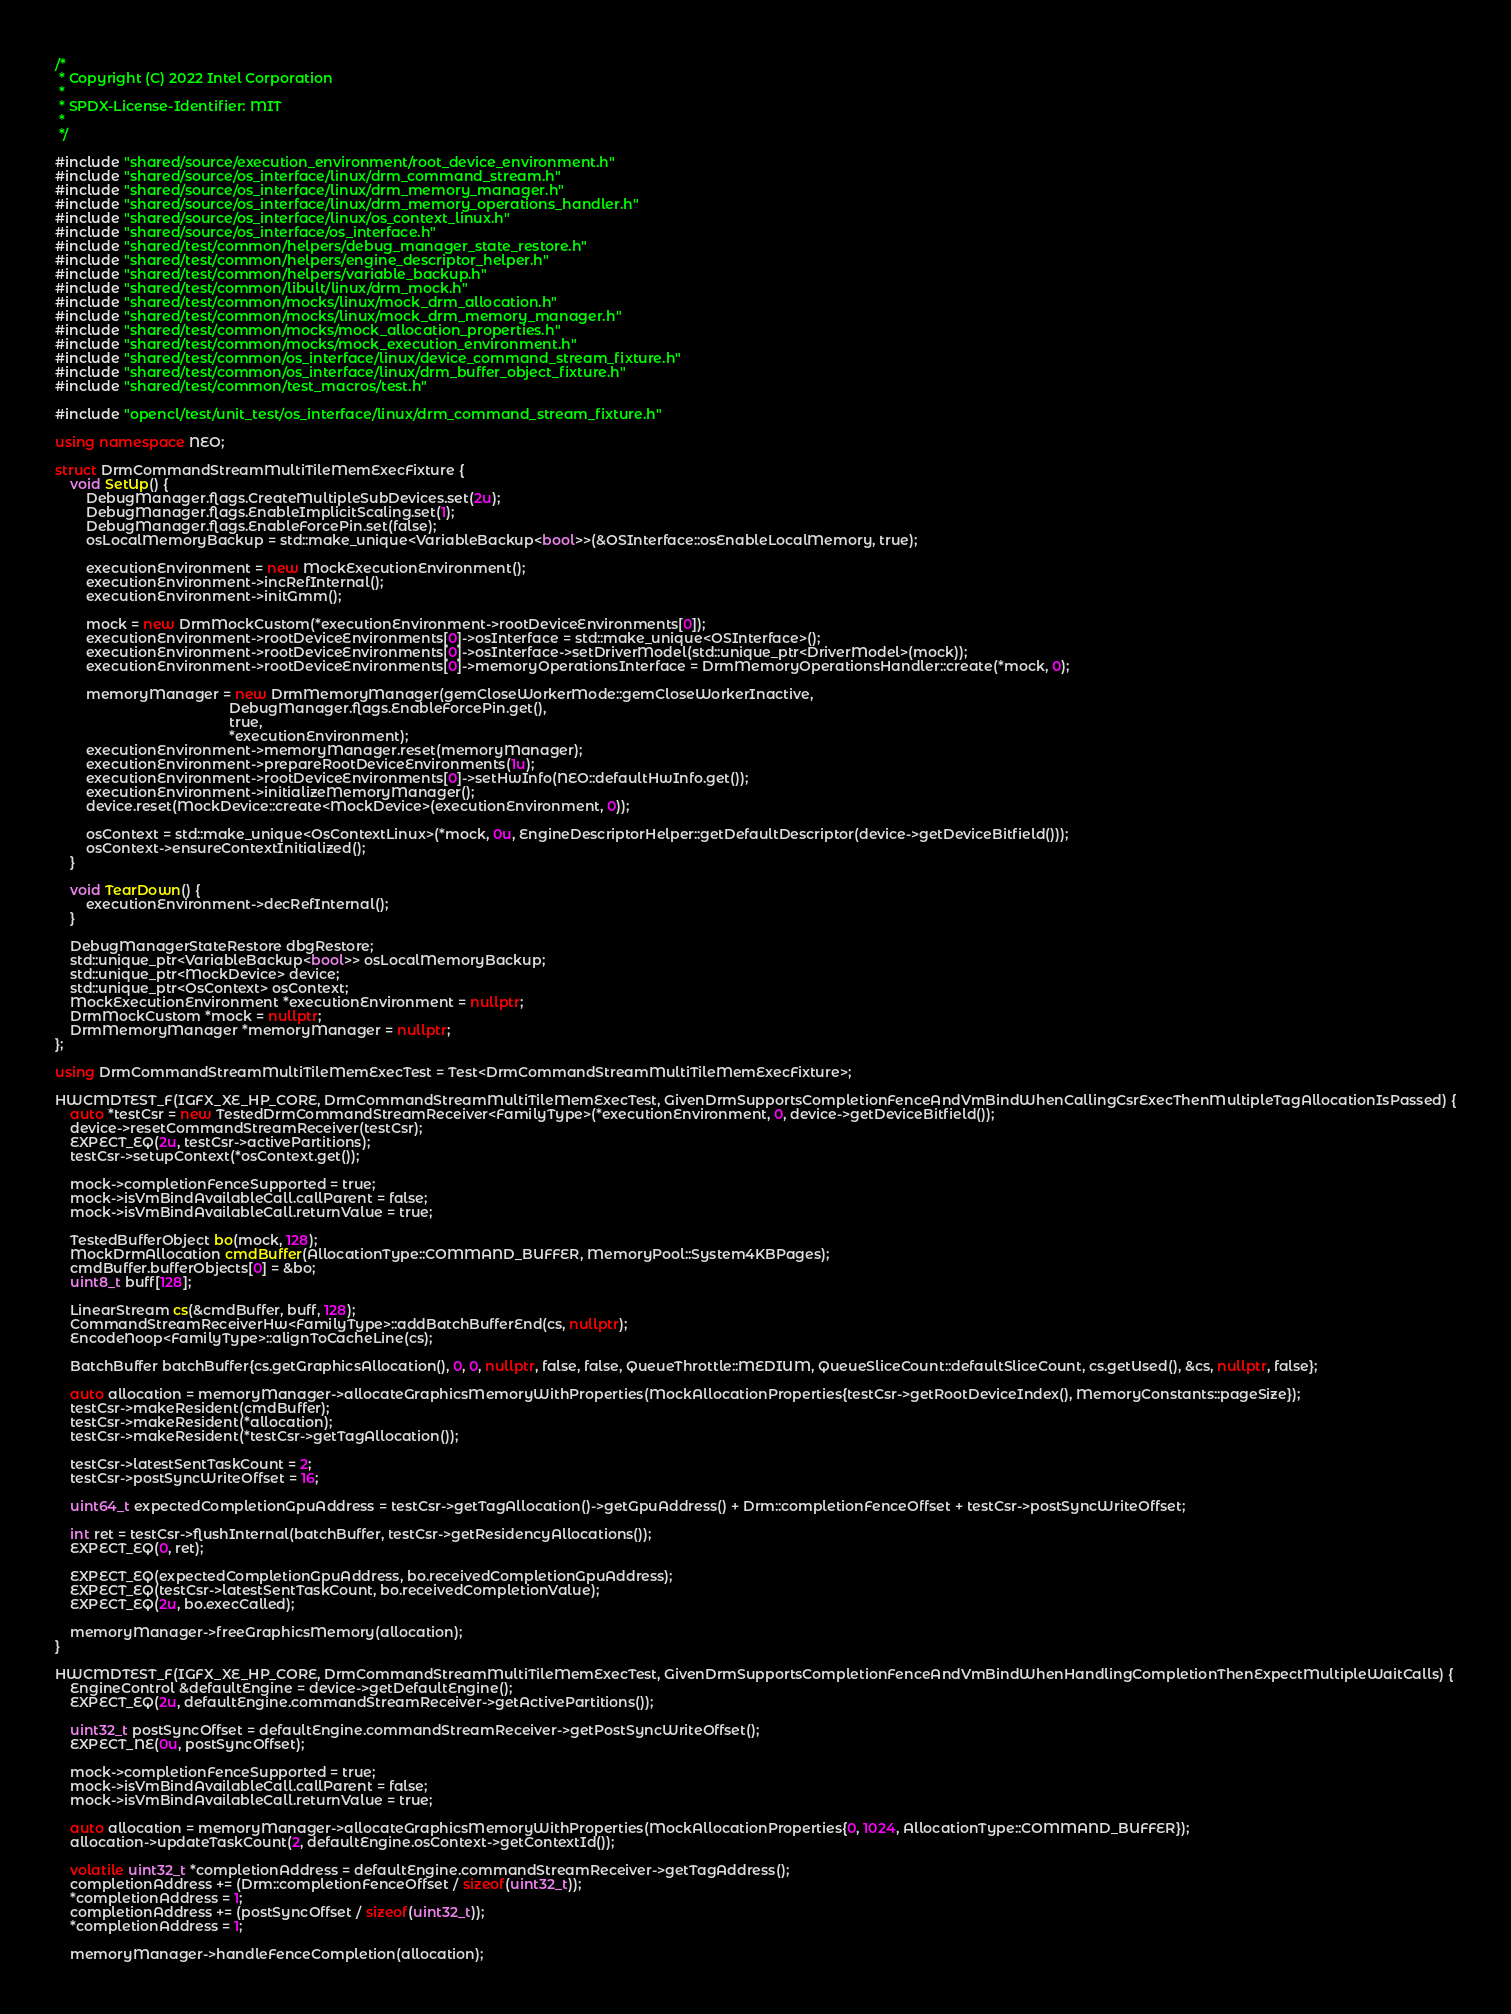<code> <loc_0><loc_0><loc_500><loc_500><_C++_>/*
 * Copyright (C) 2022 Intel Corporation
 *
 * SPDX-License-Identifier: MIT
 *
 */

#include "shared/source/execution_environment/root_device_environment.h"
#include "shared/source/os_interface/linux/drm_command_stream.h"
#include "shared/source/os_interface/linux/drm_memory_manager.h"
#include "shared/source/os_interface/linux/drm_memory_operations_handler.h"
#include "shared/source/os_interface/linux/os_context_linux.h"
#include "shared/source/os_interface/os_interface.h"
#include "shared/test/common/helpers/debug_manager_state_restore.h"
#include "shared/test/common/helpers/engine_descriptor_helper.h"
#include "shared/test/common/helpers/variable_backup.h"
#include "shared/test/common/libult/linux/drm_mock.h"
#include "shared/test/common/mocks/linux/mock_drm_allocation.h"
#include "shared/test/common/mocks/linux/mock_drm_memory_manager.h"
#include "shared/test/common/mocks/mock_allocation_properties.h"
#include "shared/test/common/mocks/mock_execution_environment.h"
#include "shared/test/common/os_interface/linux/device_command_stream_fixture.h"
#include "shared/test/common/os_interface/linux/drm_buffer_object_fixture.h"
#include "shared/test/common/test_macros/test.h"

#include "opencl/test/unit_test/os_interface/linux/drm_command_stream_fixture.h"

using namespace NEO;

struct DrmCommandStreamMultiTileMemExecFixture {
    void SetUp() {
        DebugManager.flags.CreateMultipleSubDevices.set(2u);
        DebugManager.flags.EnableImplicitScaling.set(1);
        DebugManager.flags.EnableForcePin.set(false);
        osLocalMemoryBackup = std::make_unique<VariableBackup<bool>>(&OSInterface::osEnableLocalMemory, true);

        executionEnvironment = new MockExecutionEnvironment();
        executionEnvironment->incRefInternal();
        executionEnvironment->initGmm();

        mock = new DrmMockCustom(*executionEnvironment->rootDeviceEnvironments[0]);
        executionEnvironment->rootDeviceEnvironments[0]->osInterface = std::make_unique<OSInterface>();
        executionEnvironment->rootDeviceEnvironments[0]->osInterface->setDriverModel(std::unique_ptr<DriverModel>(mock));
        executionEnvironment->rootDeviceEnvironments[0]->memoryOperationsInterface = DrmMemoryOperationsHandler::create(*mock, 0);

        memoryManager = new DrmMemoryManager(gemCloseWorkerMode::gemCloseWorkerInactive,
                                             DebugManager.flags.EnableForcePin.get(),
                                             true,
                                             *executionEnvironment);
        executionEnvironment->memoryManager.reset(memoryManager);
        executionEnvironment->prepareRootDeviceEnvironments(1u);
        executionEnvironment->rootDeviceEnvironments[0]->setHwInfo(NEO::defaultHwInfo.get());
        executionEnvironment->initializeMemoryManager();
        device.reset(MockDevice::create<MockDevice>(executionEnvironment, 0));

        osContext = std::make_unique<OsContextLinux>(*mock, 0u, EngineDescriptorHelper::getDefaultDescriptor(device->getDeviceBitfield()));
        osContext->ensureContextInitialized();
    }

    void TearDown() {
        executionEnvironment->decRefInternal();
    }

    DebugManagerStateRestore dbgRestore;
    std::unique_ptr<VariableBackup<bool>> osLocalMemoryBackup;
    std::unique_ptr<MockDevice> device;
    std::unique_ptr<OsContext> osContext;
    MockExecutionEnvironment *executionEnvironment = nullptr;
    DrmMockCustom *mock = nullptr;
    DrmMemoryManager *memoryManager = nullptr;
};

using DrmCommandStreamMultiTileMemExecTest = Test<DrmCommandStreamMultiTileMemExecFixture>;

HWCMDTEST_F(IGFX_XE_HP_CORE, DrmCommandStreamMultiTileMemExecTest, GivenDrmSupportsCompletionFenceAndVmBindWhenCallingCsrExecThenMultipleTagAllocationIsPassed) {
    auto *testCsr = new TestedDrmCommandStreamReceiver<FamilyType>(*executionEnvironment, 0, device->getDeviceBitfield());
    device->resetCommandStreamReceiver(testCsr);
    EXPECT_EQ(2u, testCsr->activePartitions);
    testCsr->setupContext(*osContext.get());

    mock->completionFenceSupported = true;
    mock->isVmBindAvailableCall.callParent = false;
    mock->isVmBindAvailableCall.returnValue = true;

    TestedBufferObject bo(mock, 128);
    MockDrmAllocation cmdBuffer(AllocationType::COMMAND_BUFFER, MemoryPool::System4KBPages);
    cmdBuffer.bufferObjects[0] = &bo;
    uint8_t buff[128];

    LinearStream cs(&cmdBuffer, buff, 128);
    CommandStreamReceiverHw<FamilyType>::addBatchBufferEnd(cs, nullptr);
    EncodeNoop<FamilyType>::alignToCacheLine(cs);

    BatchBuffer batchBuffer{cs.getGraphicsAllocation(), 0, 0, nullptr, false, false, QueueThrottle::MEDIUM, QueueSliceCount::defaultSliceCount, cs.getUsed(), &cs, nullptr, false};

    auto allocation = memoryManager->allocateGraphicsMemoryWithProperties(MockAllocationProperties{testCsr->getRootDeviceIndex(), MemoryConstants::pageSize});
    testCsr->makeResident(cmdBuffer);
    testCsr->makeResident(*allocation);
    testCsr->makeResident(*testCsr->getTagAllocation());

    testCsr->latestSentTaskCount = 2;
    testCsr->postSyncWriteOffset = 16;

    uint64_t expectedCompletionGpuAddress = testCsr->getTagAllocation()->getGpuAddress() + Drm::completionFenceOffset + testCsr->postSyncWriteOffset;

    int ret = testCsr->flushInternal(batchBuffer, testCsr->getResidencyAllocations());
    EXPECT_EQ(0, ret);

    EXPECT_EQ(expectedCompletionGpuAddress, bo.receivedCompletionGpuAddress);
    EXPECT_EQ(testCsr->latestSentTaskCount, bo.receivedCompletionValue);
    EXPECT_EQ(2u, bo.execCalled);

    memoryManager->freeGraphicsMemory(allocation);
}

HWCMDTEST_F(IGFX_XE_HP_CORE, DrmCommandStreamMultiTileMemExecTest, GivenDrmSupportsCompletionFenceAndVmBindWhenHandlingCompletionThenExpectMultipleWaitCalls) {
    EngineControl &defaultEngine = device->getDefaultEngine();
    EXPECT_EQ(2u, defaultEngine.commandStreamReceiver->getActivePartitions());

    uint32_t postSyncOffset = defaultEngine.commandStreamReceiver->getPostSyncWriteOffset();
    EXPECT_NE(0u, postSyncOffset);

    mock->completionFenceSupported = true;
    mock->isVmBindAvailableCall.callParent = false;
    mock->isVmBindAvailableCall.returnValue = true;

    auto allocation = memoryManager->allocateGraphicsMemoryWithProperties(MockAllocationProperties{0, 1024, AllocationType::COMMAND_BUFFER});
    allocation->updateTaskCount(2, defaultEngine.osContext->getContextId());

    volatile uint32_t *completionAddress = defaultEngine.commandStreamReceiver->getTagAddress();
    completionAddress += (Drm::completionFenceOffset / sizeof(uint32_t));
    *completionAddress = 1;
    completionAddress += (postSyncOffset / sizeof(uint32_t));
    *completionAddress = 1;

    memoryManager->handleFenceCompletion(allocation);
</code> 